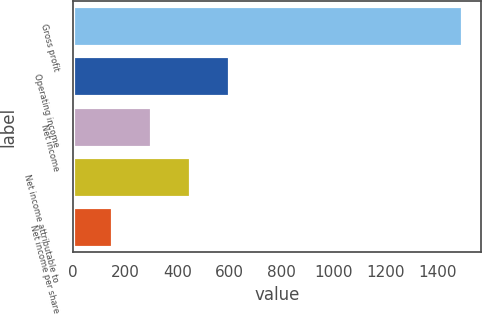Convert chart to OTSL. <chart><loc_0><loc_0><loc_500><loc_500><bar_chart><fcel>Gross profit<fcel>Operating income<fcel>Net income<fcel>Net income attributable to<fcel>Net income per share<nl><fcel>1492<fcel>596.99<fcel>298.65<fcel>447.82<fcel>149.48<nl></chart> 